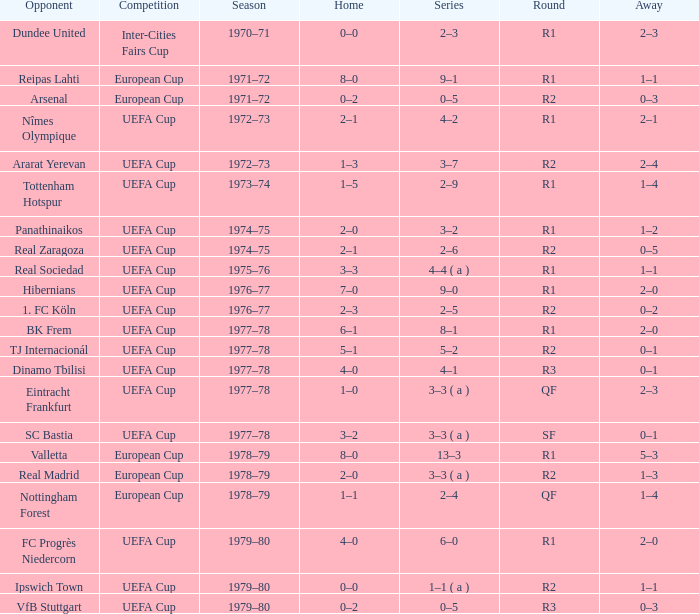Which Season has an Opponent of hibernians? 1976–77. 